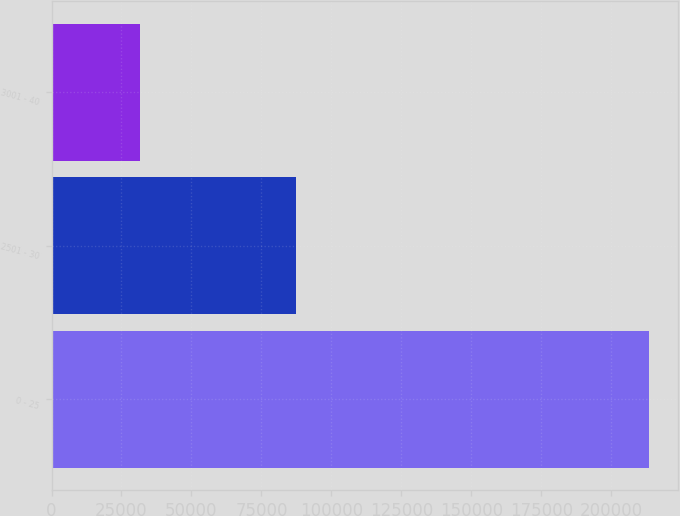<chart> <loc_0><loc_0><loc_500><loc_500><bar_chart><fcel>0 - 25<fcel>2501 - 30<fcel>3001 - 40<nl><fcel>213308<fcel>87521<fcel>31740<nl></chart> 